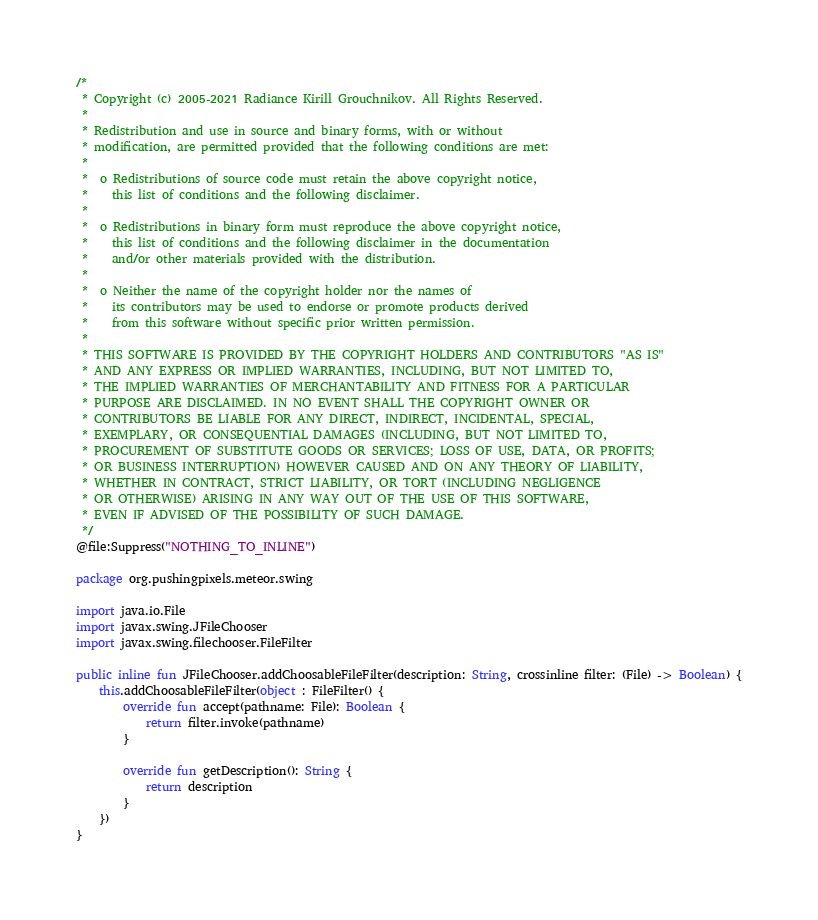<code> <loc_0><loc_0><loc_500><loc_500><_Kotlin_>/*
 * Copyright (c) 2005-2021 Radiance Kirill Grouchnikov. All Rights Reserved.
 *
 * Redistribution and use in source and binary forms, with or without
 * modification, are permitted provided that the following conditions are met:
 *
 *  o Redistributions of source code must retain the above copyright notice,
 *    this list of conditions and the following disclaimer.
 *
 *  o Redistributions in binary form must reproduce the above copyright notice,
 *    this list of conditions and the following disclaimer in the documentation
 *    and/or other materials provided with the distribution.
 *
 *  o Neither the name of the copyright holder nor the names of
 *    its contributors may be used to endorse or promote products derived
 *    from this software without specific prior written permission.
 *
 * THIS SOFTWARE IS PROVIDED BY THE COPYRIGHT HOLDERS AND CONTRIBUTORS "AS IS"
 * AND ANY EXPRESS OR IMPLIED WARRANTIES, INCLUDING, BUT NOT LIMITED TO,
 * THE IMPLIED WARRANTIES OF MERCHANTABILITY AND FITNESS FOR A PARTICULAR
 * PURPOSE ARE DISCLAIMED. IN NO EVENT SHALL THE COPYRIGHT OWNER OR
 * CONTRIBUTORS BE LIABLE FOR ANY DIRECT, INDIRECT, INCIDENTAL, SPECIAL,
 * EXEMPLARY, OR CONSEQUENTIAL DAMAGES (INCLUDING, BUT NOT LIMITED TO,
 * PROCUREMENT OF SUBSTITUTE GOODS OR SERVICES; LOSS OF USE, DATA, OR PROFITS;
 * OR BUSINESS INTERRUPTION) HOWEVER CAUSED AND ON ANY THEORY OF LIABILITY,
 * WHETHER IN CONTRACT, STRICT LIABILITY, OR TORT (INCLUDING NEGLIGENCE
 * OR OTHERWISE) ARISING IN ANY WAY OUT OF THE USE OF THIS SOFTWARE,
 * EVEN IF ADVISED OF THE POSSIBILITY OF SUCH DAMAGE.
 */
@file:Suppress("NOTHING_TO_INLINE")

package org.pushingpixels.meteor.swing

import java.io.File
import javax.swing.JFileChooser
import javax.swing.filechooser.FileFilter

public inline fun JFileChooser.addChoosableFileFilter(description: String, crossinline filter: (File) -> Boolean) {
    this.addChoosableFileFilter(object : FileFilter() {
        override fun accept(pathname: File): Boolean {
            return filter.invoke(pathname)
        }

        override fun getDescription(): String {
            return description
        }
    })
}

</code> 